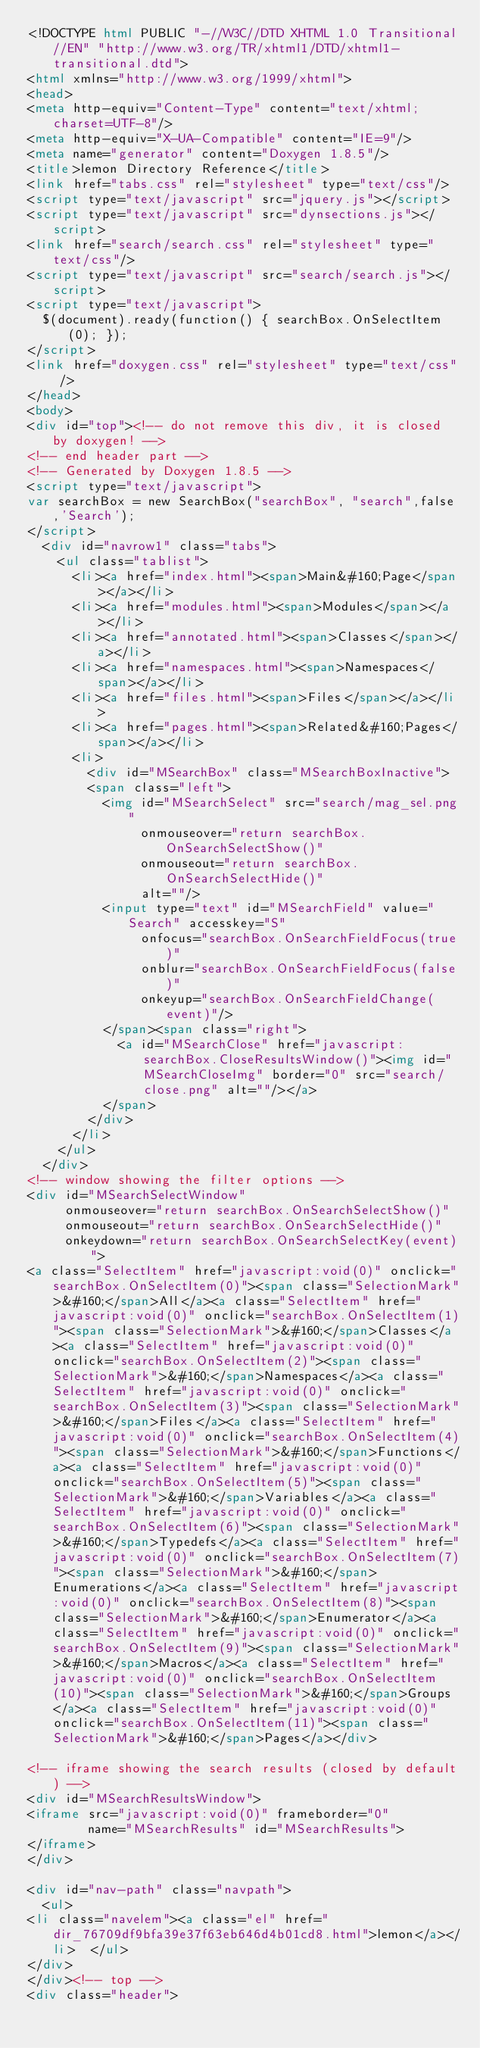<code> <loc_0><loc_0><loc_500><loc_500><_HTML_><!DOCTYPE html PUBLIC "-//W3C//DTD XHTML 1.0 Transitional//EN" "http://www.w3.org/TR/xhtml1/DTD/xhtml1-transitional.dtd">
<html xmlns="http://www.w3.org/1999/xhtml">
<head>
<meta http-equiv="Content-Type" content="text/xhtml;charset=UTF-8"/>
<meta http-equiv="X-UA-Compatible" content="IE=9"/>
<meta name="generator" content="Doxygen 1.8.5"/>
<title>lemon Directory Reference</title>
<link href="tabs.css" rel="stylesheet" type="text/css"/>
<script type="text/javascript" src="jquery.js"></script>
<script type="text/javascript" src="dynsections.js"></script>
<link href="search/search.css" rel="stylesheet" type="text/css"/>
<script type="text/javascript" src="search/search.js"></script>
<script type="text/javascript">
  $(document).ready(function() { searchBox.OnSelectItem(0); });
</script>
<link href="doxygen.css" rel="stylesheet" type="text/css" />
</head>
<body>
<div id="top"><!-- do not remove this div, it is closed by doxygen! -->
<!-- end header part -->
<!-- Generated by Doxygen 1.8.5 -->
<script type="text/javascript">
var searchBox = new SearchBox("searchBox", "search",false,'Search');
</script>
  <div id="navrow1" class="tabs">
    <ul class="tablist">
      <li><a href="index.html"><span>Main&#160;Page</span></a></li>
      <li><a href="modules.html"><span>Modules</span></a></li>
      <li><a href="annotated.html"><span>Classes</span></a></li>
      <li><a href="namespaces.html"><span>Namespaces</span></a></li>
      <li><a href="files.html"><span>Files</span></a></li>
      <li><a href="pages.html"><span>Related&#160;Pages</span></a></li>
      <li>
        <div id="MSearchBox" class="MSearchBoxInactive">
        <span class="left">
          <img id="MSearchSelect" src="search/mag_sel.png"
               onmouseover="return searchBox.OnSearchSelectShow()"
               onmouseout="return searchBox.OnSearchSelectHide()"
               alt=""/>
          <input type="text" id="MSearchField" value="Search" accesskey="S"
               onfocus="searchBox.OnSearchFieldFocus(true)" 
               onblur="searchBox.OnSearchFieldFocus(false)" 
               onkeyup="searchBox.OnSearchFieldChange(event)"/>
          </span><span class="right">
            <a id="MSearchClose" href="javascript:searchBox.CloseResultsWindow()"><img id="MSearchCloseImg" border="0" src="search/close.png" alt=""/></a>
          </span>
        </div>
      </li>
    </ul>
  </div>
<!-- window showing the filter options -->
<div id="MSearchSelectWindow"
     onmouseover="return searchBox.OnSearchSelectShow()"
     onmouseout="return searchBox.OnSearchSelectHide()"
     onkeydown="return searchBox.OnSearchSelectKey(event)">
<a class="SelectItem" href="javascript:void(0)" onclick="searchBox.OnSelectItem(0)"><span class="SelectionMark">&#160;</span>All</a><a class="SelectItem" href="javascript:void(0)" onclick="searchBox.OnSelectItem(1)"><span class="SelectionMark">&#160;</span>Classes</a><a class="SelectItem" href="javascript:void(0)" onclick="searchBox.OnSelectItem(2)"><span class="SelectionMark">&#160;</span>Namespaces</a><a class="SelectItem" href="javascript:void(0)" onclick="searchBox.OnSelectItem(3)"><span class="SelectionMark">&#160;</span>Files</a><a class="SelectItem" href="javascript:void(0)" onclick="searchBox.OnSelectItem(4)"><span class="SelectionMark">&#160;</span>Functions</a><a class="SelectItem" href="javascript:void(0)" onclick="searchBox.OnSelectItem(5)"><span class="SelectionMark">&#160;</span>Variables</a><a class="SelectItem" href="javascript:void(0)" onclick="searchBox.OnSelectItem(6)"><span class="SelectionMark">&#160;</span>Typedefs</a><a class="SelectItem" href="javascript:void(0)" onclick="searchBox.OnSelectItem(7)"><span class="SelectionMark">&#160;</span>Enumerations</a><a class="SelectItem" href="javascript:void(0)" onclick="searchBox.OnSelectItem(8)"><span class="SelectionMark">&#160;</span>Enumerator</a><a class="SelectItem" href="javascript:void(0)" onclick="searchBox.OnSelectItem(9)"><span class="SelectionMark">&#160;</span>Macros</a><a class="SelectItem" href="javascript:void(0)" onclick="searchBox.OnSelectItem(10)"><span class="SelectionMark">&#160;</span>Groups</a><a class="SelectItem" href="javascript:void(0)" onclick="searchBox.OnSelectItem(11)"><span class="SelectionMark">&#160;</span>Pages</a></div>

<!-- iframe showing the search results (closed by default) -->
<div id="MSearchResultsWindow">
<iframe src="javascript:void(0)" frameborder="0" 
        name="MSearchResults" id="MSearchResults">
</iframe>
</div>

<div id="nav-path" class="navpath">
  <ul>
<li class="navelem"><a class="el" href="dir_76709df9bfa39e37f63eb646d4b01cd8.html">lemon</a></li>  </ul>
</div>
</div><!-- top -->
<div class="header"></code> 